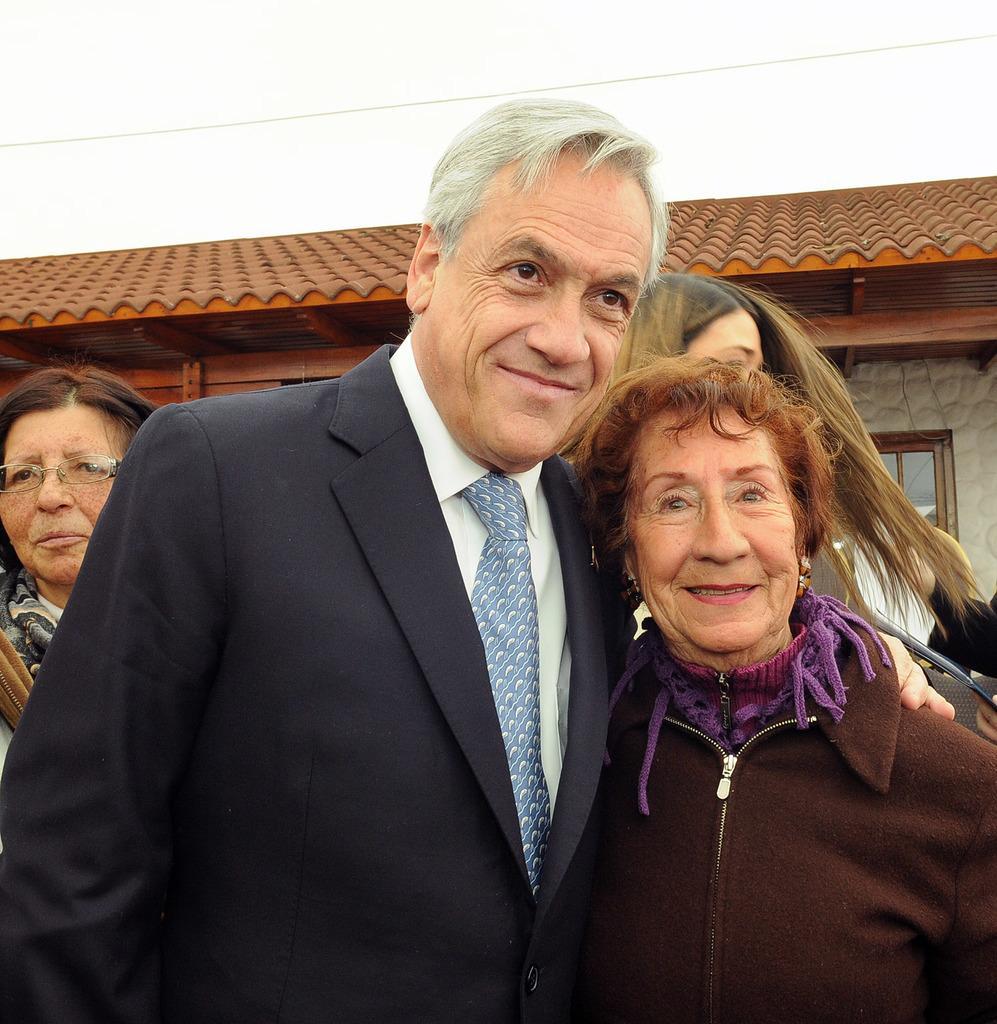Could you give a brief overview of what you see in this image? In this image we can see a group of people standing. On the backside we can see a house with roof and windows, a wire and the sky. 